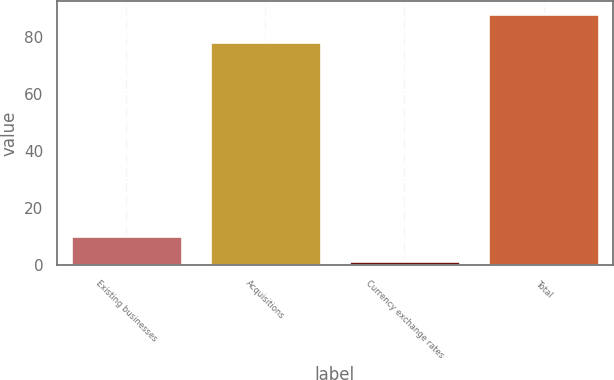Convert chart to OTSL. <chart><loc_0><loc_0><loc_500><loc_500><bar_chart><fcel>Existing businesses<fcel>Acquisitions<fcel>Currency exchange rates<fcel>Total<nl><fcel>10.15<fcel>78<fcel>1.5<fcel>88<nl></chart> 